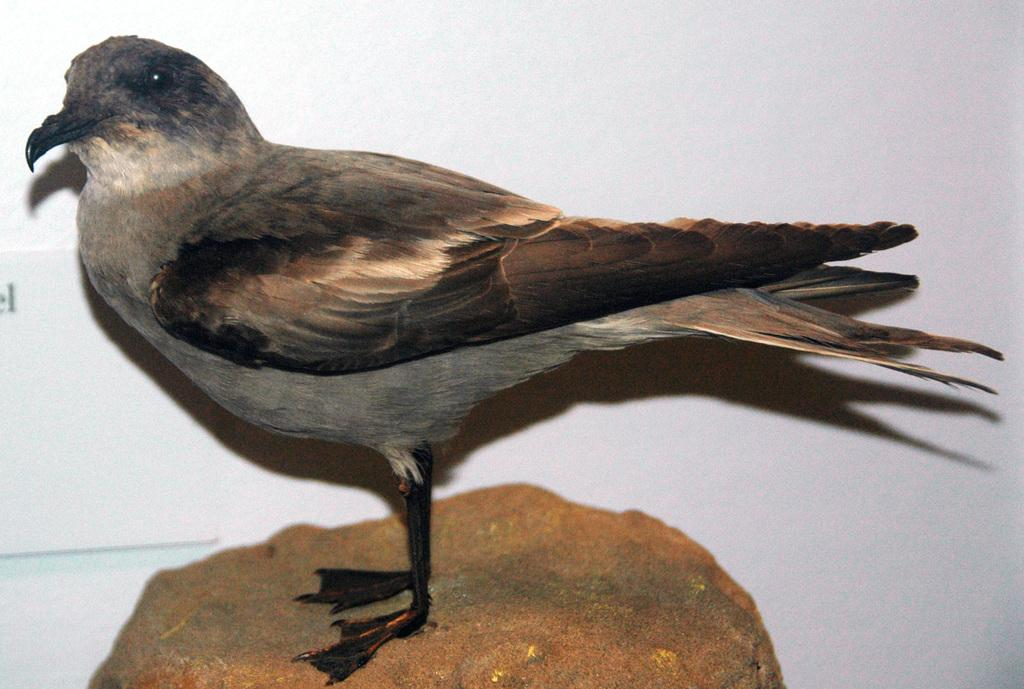What type of animal is present on the surface in the image? There is a bird on the surface in the image. What can be seen in the background of the image? There is a wall in the background of the image. How many buns are being used as a pillow for the snakes in the image? There are no buns or snakes present in the image; it features a bird on a surface with a wall in the background. 